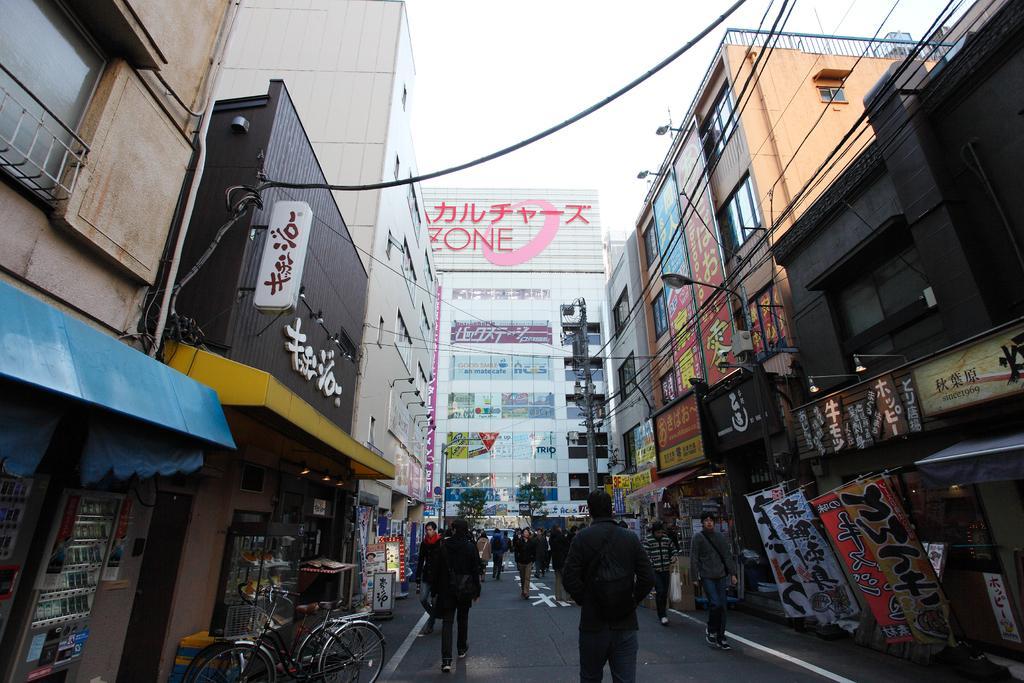In one or two sentences, can you explain what this image depicts? This image is taken outdoors. At the bottom of the image there is a road. In the middle of the image a few people are walking on the road and there is a building with many boards and text on them and there is a pole. On the left side of the image there are two buildings and there are a few boards with text on them and a bicycle is parked on the road. On the right side of the image there are a few buildings and there are many boards with text on them and there is a street light. There are a few wires. 